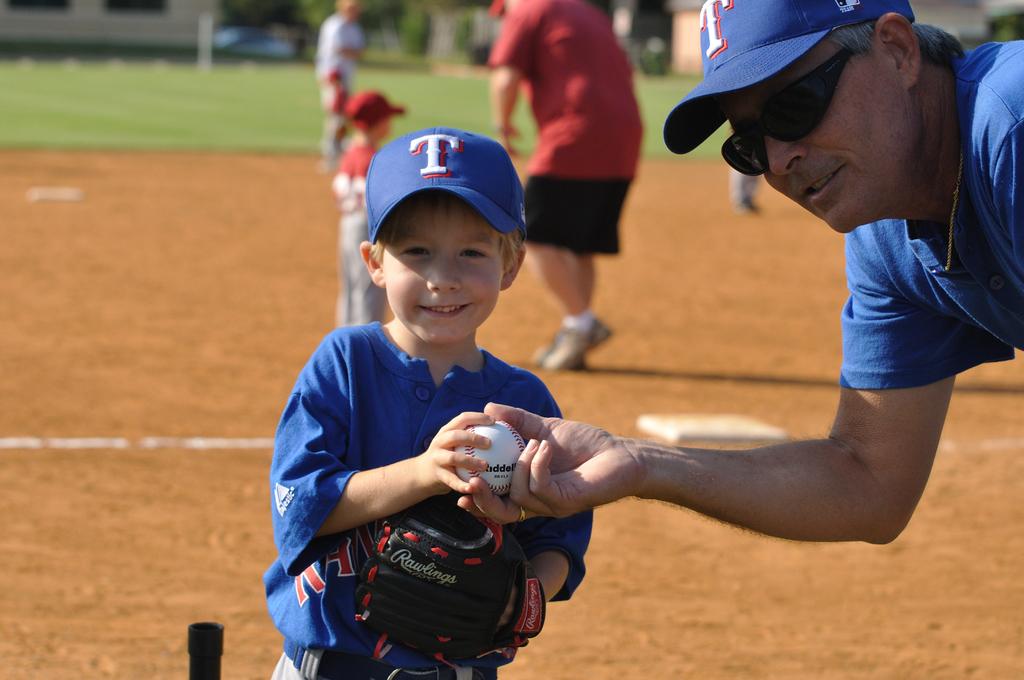Who made this boy's glove?
Your answer should be very brief. Rawlings. What letter is on the player's hat?
Give a very brief answer. T. 